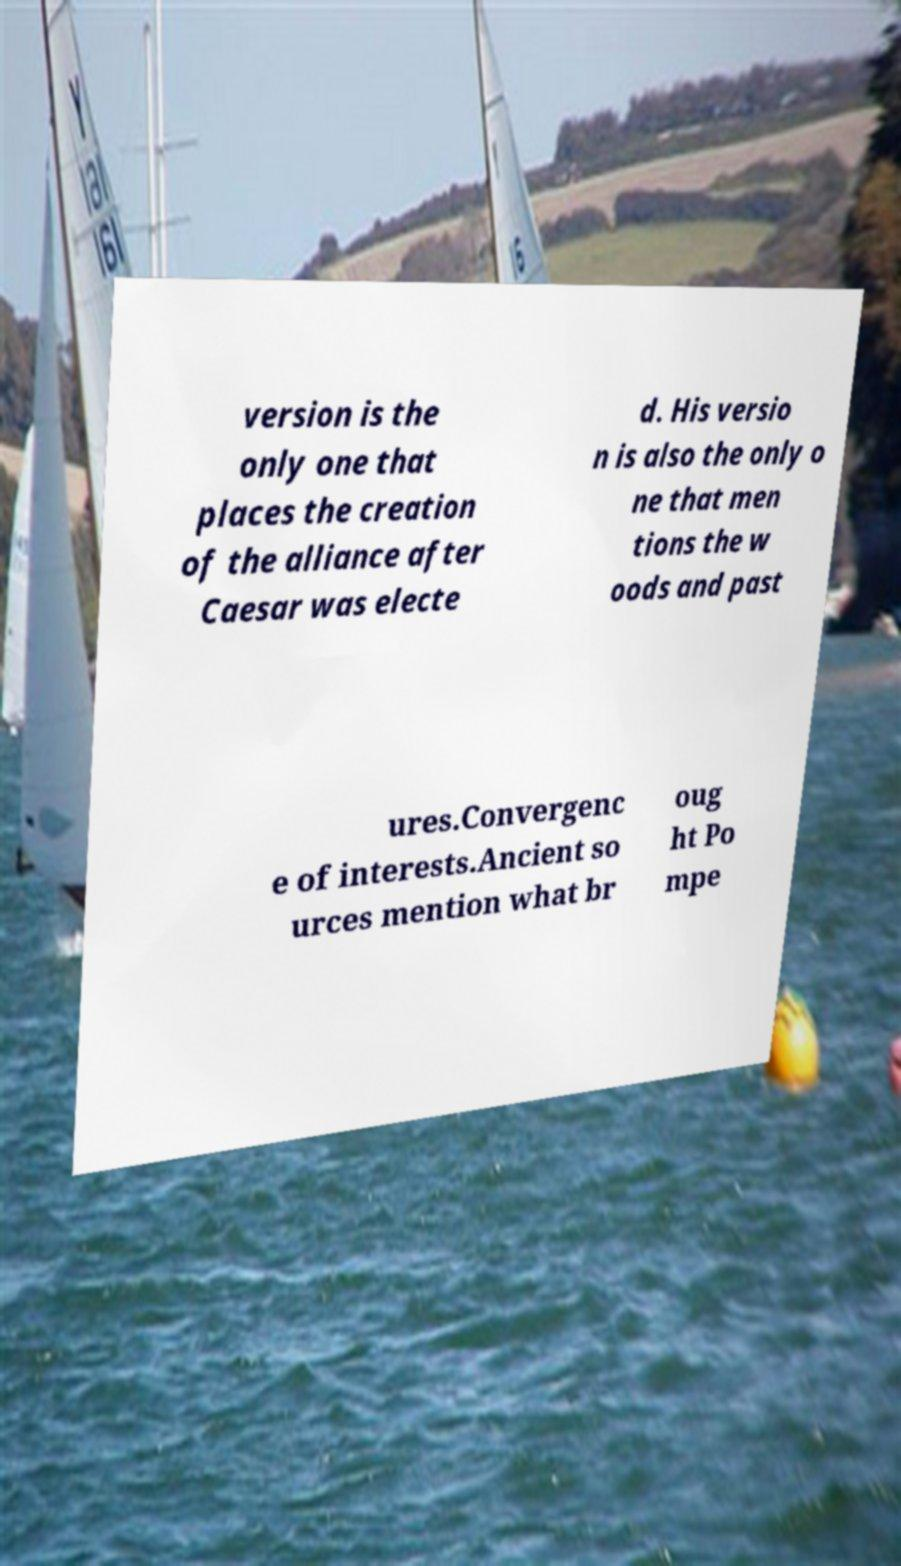Please read and relay the text visible in this image. What does it say? version is the only one that places the creation of the alliance after Caesar was electe d. His versio n is also the only o ne that men tions the w oods and past ures.Convergenc e of interests.Ancient so urces mention what br oug ht Po mpe 